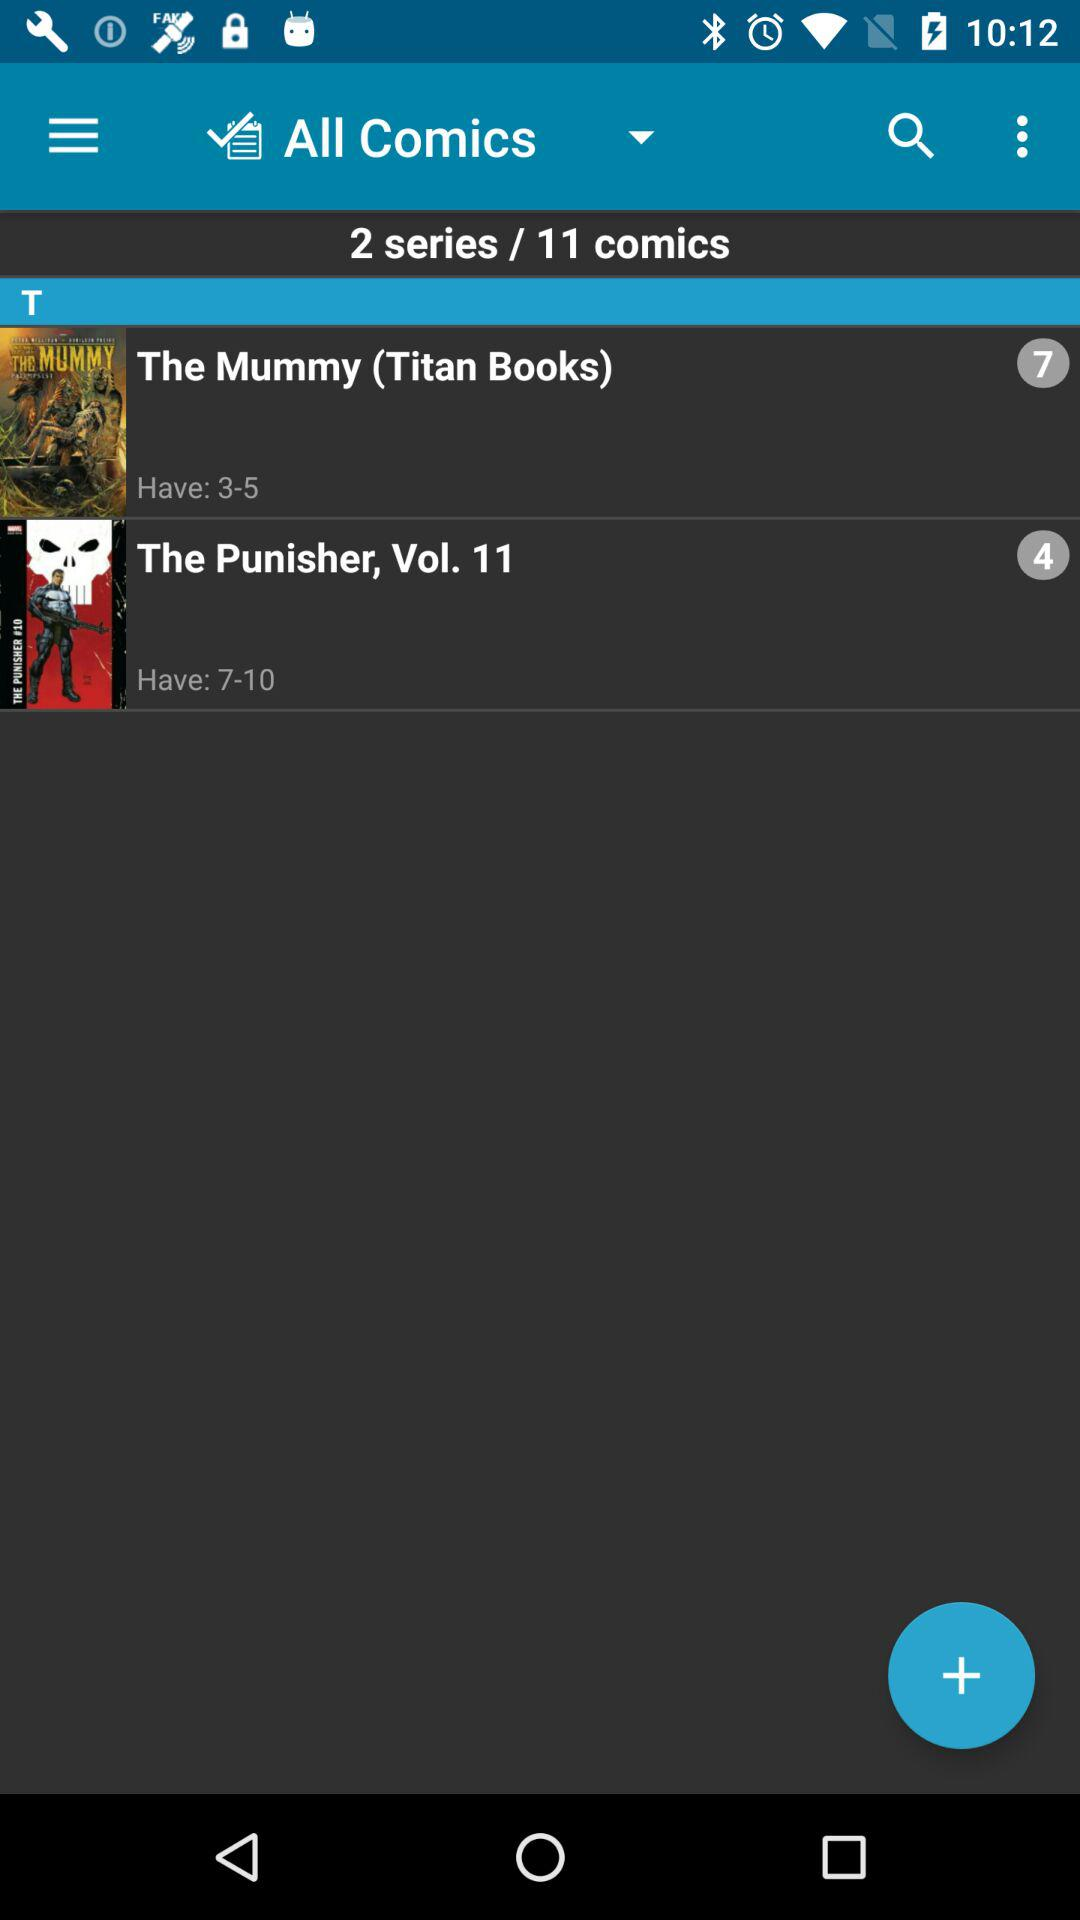How many comics are there in total?
Answer the question using a single word or phrase. 11 